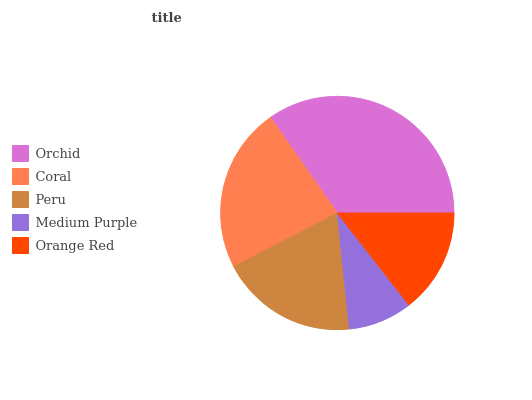Is Medium Purple the minimum?
Answer yes or no. Yes. Is Orchid the maximum?
Answer yes or no. Yes. Is Coral the minimum?
Answer yes or no. No. Is Coral the maximum?
Answer yes or no. No. Is Orchid greater than Coral?
Answer yes or no. Yes. Is Coral less than Orchid?
Answer yes or no. Yes. Is Coral greater than Orchid?
Answer yes or no. No. Is Orchid less than Coral?
Answer yes or no. No. Is Peru the high median?
Answer yes or no. Yes. Is Peru the low median?
Answer yes or no. Yes. Is Orange Red the high median?
Answer yes or no. No. Is Coral the low median?
Answer yes or no. No. 